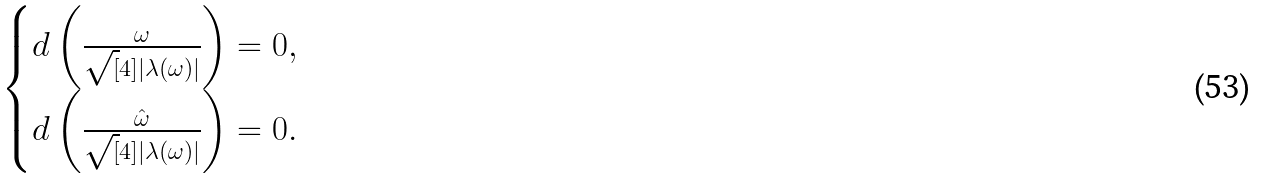<formula> <loc_0><loc_0><loc_500><loc_500>\begin{cases} d \left ( \frac { \omega } { \sqrt { [ } 4 ] { | \lambda ( \omega ) | } } \right ) = 0 , & \\ d \left ( \frac { \hat { \omega } } { \sqrt { [ } 4 ] { | \lambda ( \omega ) | } } \right ) = 0 . & \\ \end{cases}</formula> 